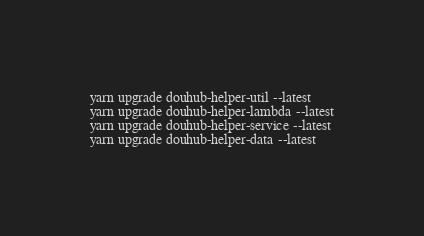<code> <loc_0><loc_0><loc_500><loc_500><_Bash_>yarn upgrade douhub-helper-util --latest
yarn upgrade douhub-helper-lambda --latest
yarn upgrade douhub-helper-service --latest
yarn upgrade douhub-helper-data --latest
</code> 